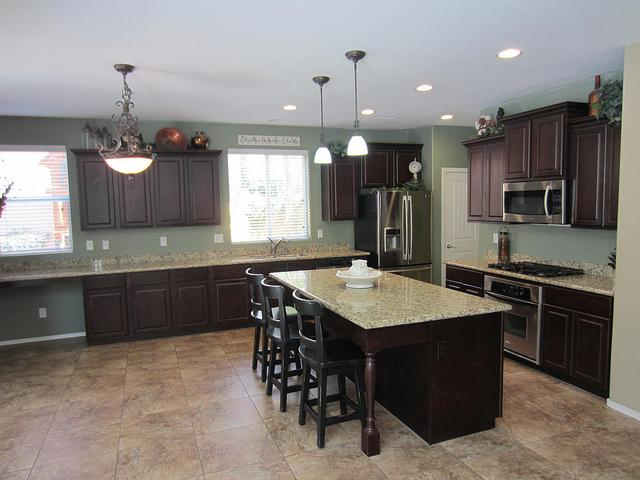What is the right side of the room mainly used for?

Choices:
A) sleeping
B) gaming
C) bathing
D) cooking cooking 